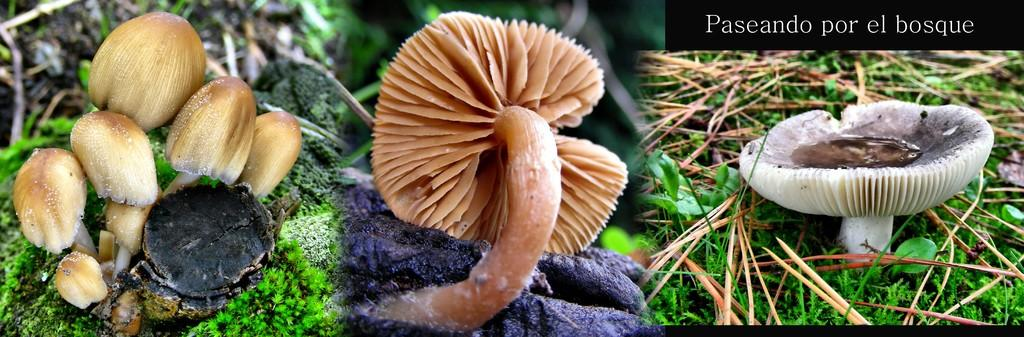What type of images are present in the collage in the image? There are collage pictures in the image. What other elements can be seen in the image besides the collage? There are plants visible in the image. Where is the text located in the image? The text is written in the top right corner of the image. What type of request does the dad make in the image? There is no dad or request present in the image; it only contains collage pictures, plants, and text. 